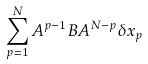<formula> <loc_0><loc_0><loc_500><loc_500>\sum _ { p = 1 } ^ { N } A ^ { p - 1 } B A ^ { N - p } \delta x _ { p }</formula> 